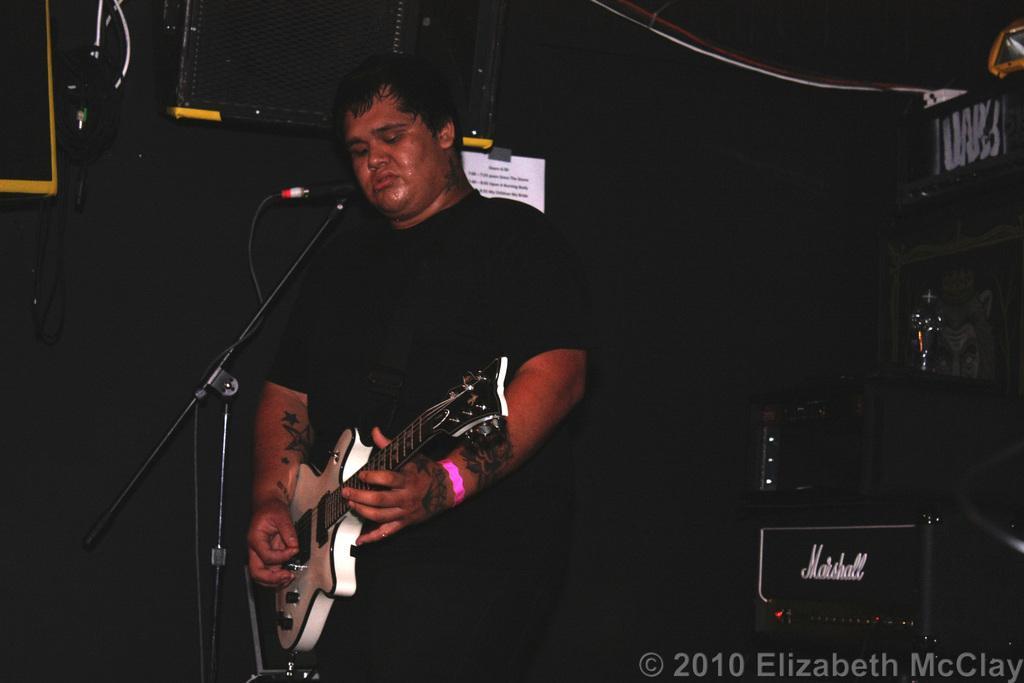Can you describe this image briefly? I could see a person holding a guitar in his hands and dressed black in color standing in front of the mic and the background is black in color. 